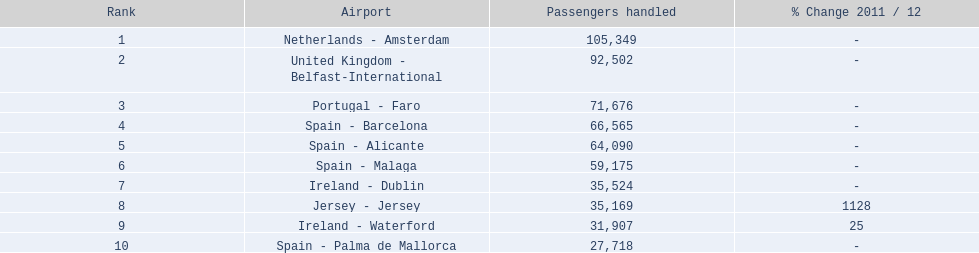What are all the ways out of london southend airport? Netherlands - Amsterdam, United Kingdom - Belfast-International, Portugal - Faro, Spain - Barcelona, Spain - Alicante, Spain - Malaga, Ireland - Dublin, Jersey - Jersey, Ireland - Waterford, Spain - Palma de Mallorca. How many passengers have gone to each endpoint? 105,349, 92,502, 71,676, 66,565, 64,090, 59,175, 35,524, 35,169, 31,907, 27,718. And which endpoint has been the most preferred by passengers? Netherlands - Amsterdam. 